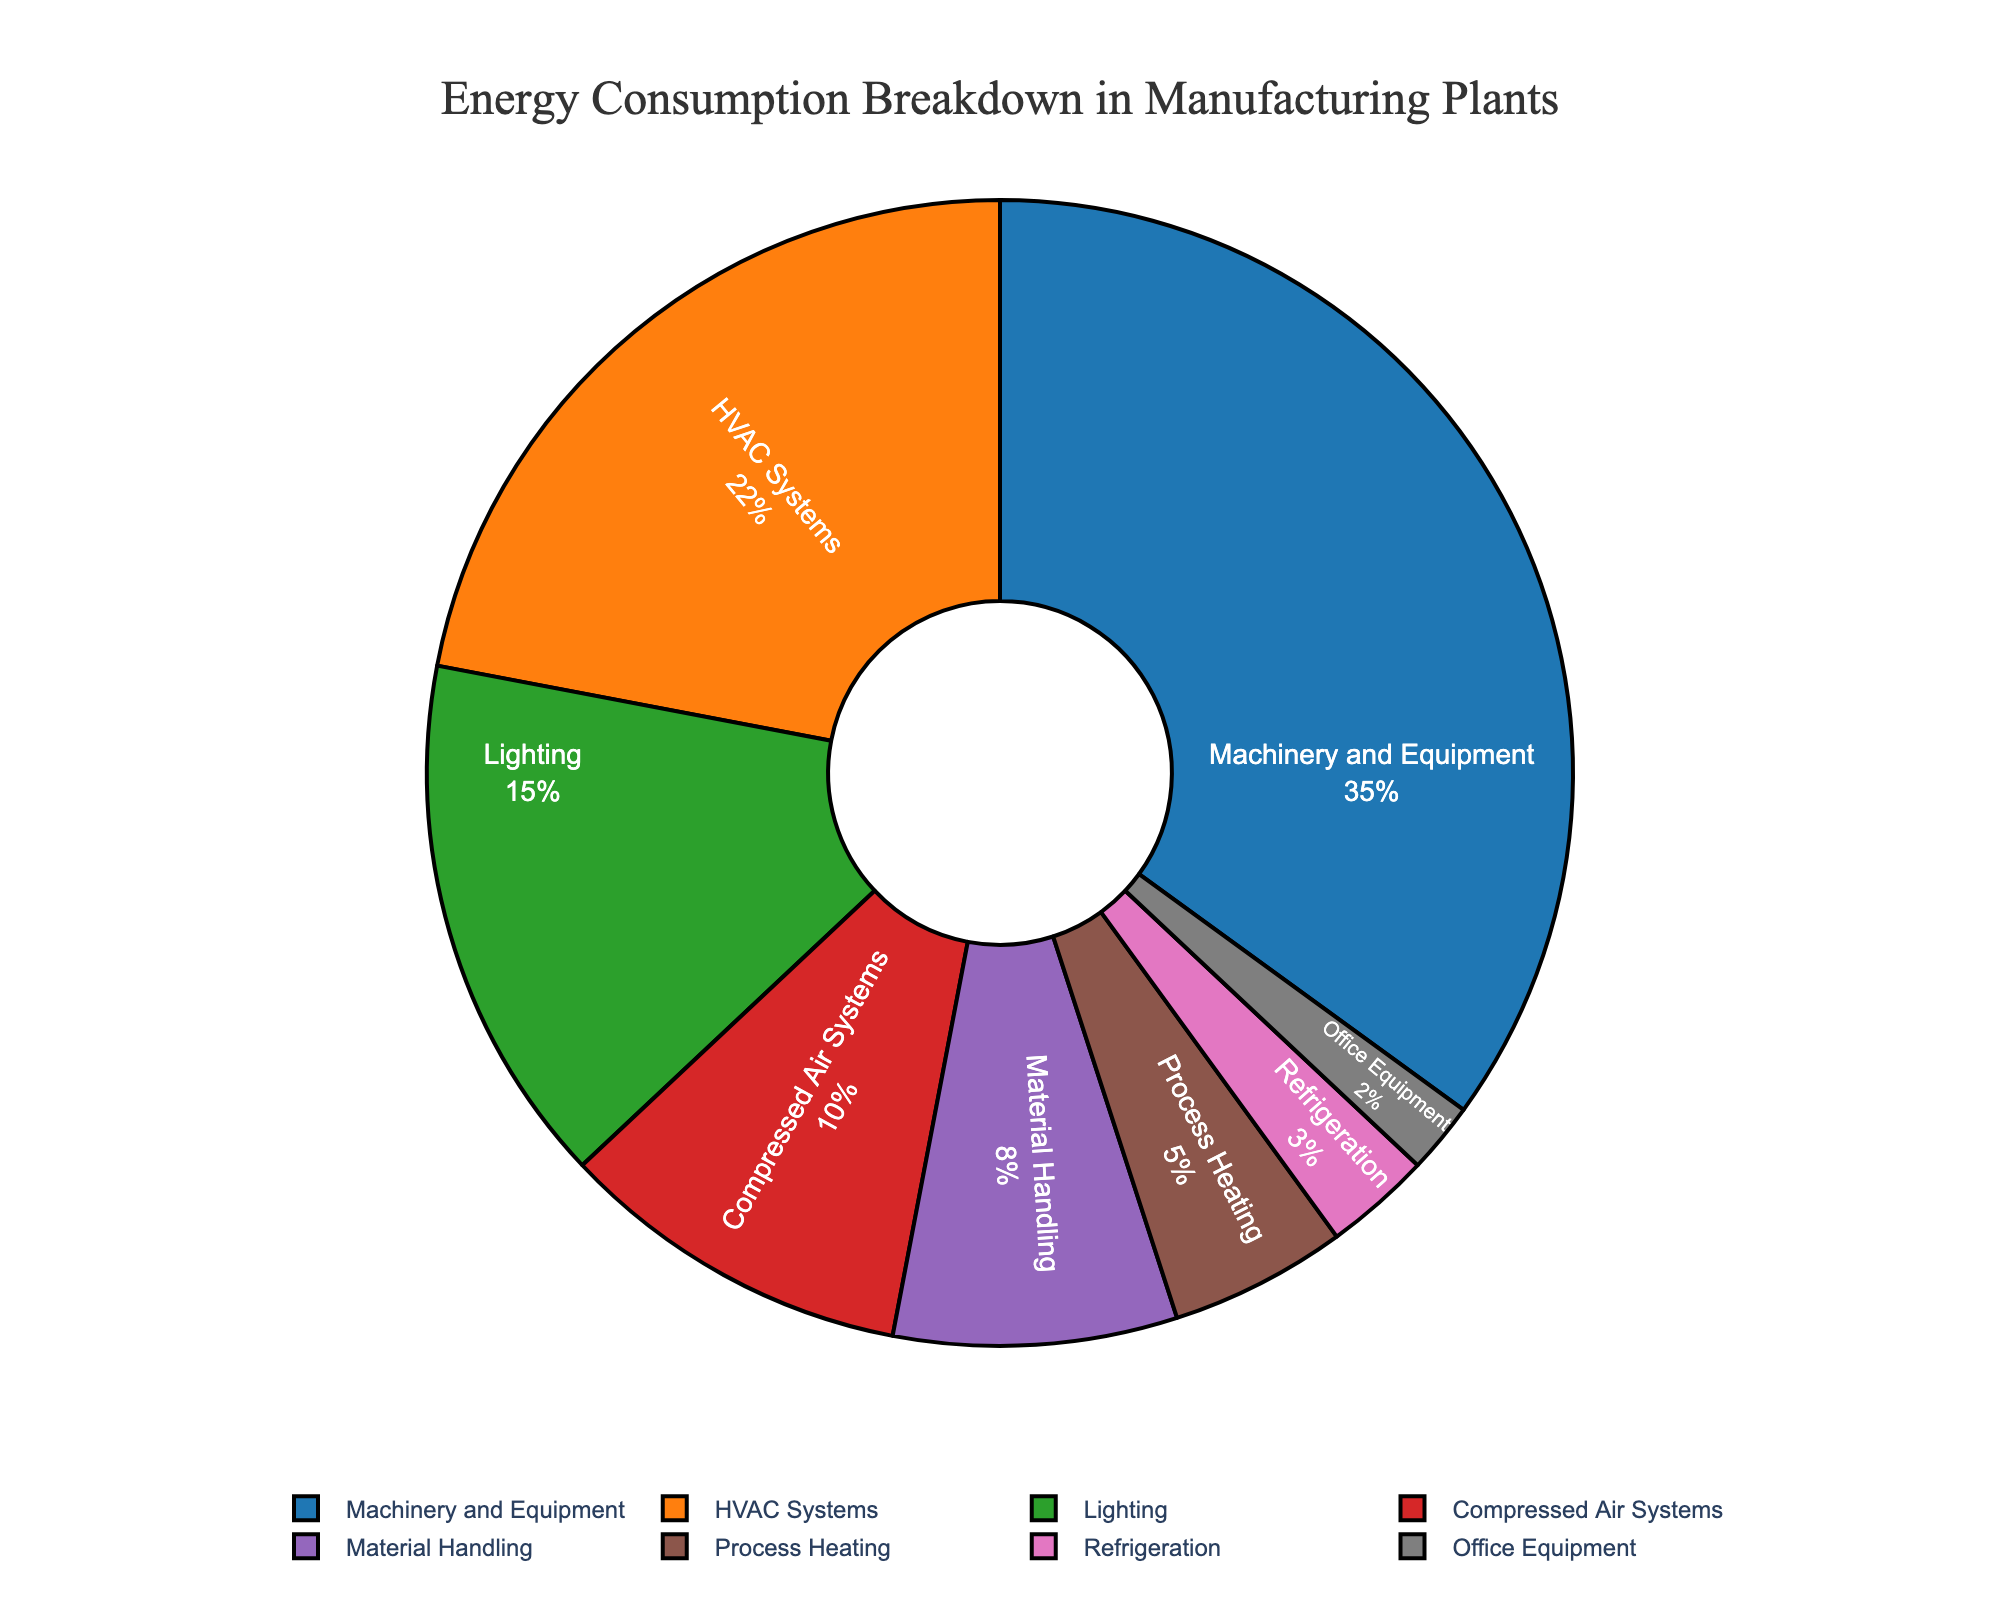Which process consumes the most energy in the manufacturing plants? The section of the pie chart with the highest percentage will represent the process that consumes the most energy. In this case, the "Machinery and Equipment" section is the largest with 35% of the energy consumption.
Answer: Machinery and Equipment What is the combined percentage of energy consumed by HVAC Systems and Lighting? To find the combined percentage, add the individual percentages of HVAC Systems and Lighting. HVAC Systems consume 22%, and Lighting consumes 15%, so their combined percentage is 22% + 15% = 37%.
Answer: 37% Is the energy consumed by Compressed Air Systems greater than that by Material Handling? By comparing the percentages, Compressed Air Systems consume 10% and Material Handling consumes 8%. Since 10% > 8%, Compressed Air Systems consume more energy than Material Handling.
Answer: Yes Which process consumes the least energy? The smallest section in the pie chart will indicate the process with the least energy consumption. The "Office Equipment" section is the smallest with 2% of the energy consumption.
Answer: Office Equipment What is the difference in energy consumption between Machinery and Equipment and Process Heating? Subtract the percentage of Process Heating from the percentage of Machinery and Equipment. The difference is 35% - 5% = 30%.
Answer: 30% What processes together make up half of the total energy consumption? To find which processes together make up 50% (half) of the total energy consumption, you need to sum the percentages. Adding up "Machinery and Equipment" (35%) and "HVAC Systems" (22%) gives 57%, which exceeds 50%. Thus, you should consider smaller processes. Combining "Machinery and Equipment" (35%), "Lighting" (15%), and "Compressed Air Systems" (10%) results in exactly 60%, which is also greater than 50%. Therefore, the processes to consider are "Machinery and Equipment", "Lighting", and any combinations summing up to or just above 50%. "Machinery and Equipment" and "Lighting" alone sum up to 50%.
Answer: Machinery and Equipment, Lighting What proportion of energy is consumed by processes other than Machinery and Equipment? To find the proportion of energy consumed by all processes other than Machinery and Equipment, subtract the percentage consumed by Machinery and Equipment from 100%. This is 100% - 35% = 65%.
Answer: 65% Are the combined energy consumptions of Material Handling and Process Heating less than the energy consumed by HVAC Systems? Summing the percentages of Material Handling (8%) and Process Heating (5%) gives 8% + 5% = 13%. Since 13% is less than the 22% consumed by HVAC Systems, the combined energy consumption of Material Handling and Process Heating is less.
Answer: Yes What is the combined percentage of energy consumed by office-related processes (Office Equipment and Lighting)? Adding the percentages of Office Equipment (2%) and Lighting (15%) gives a combined percentage of 2% + 15% = 17%.
Answer: 17% 